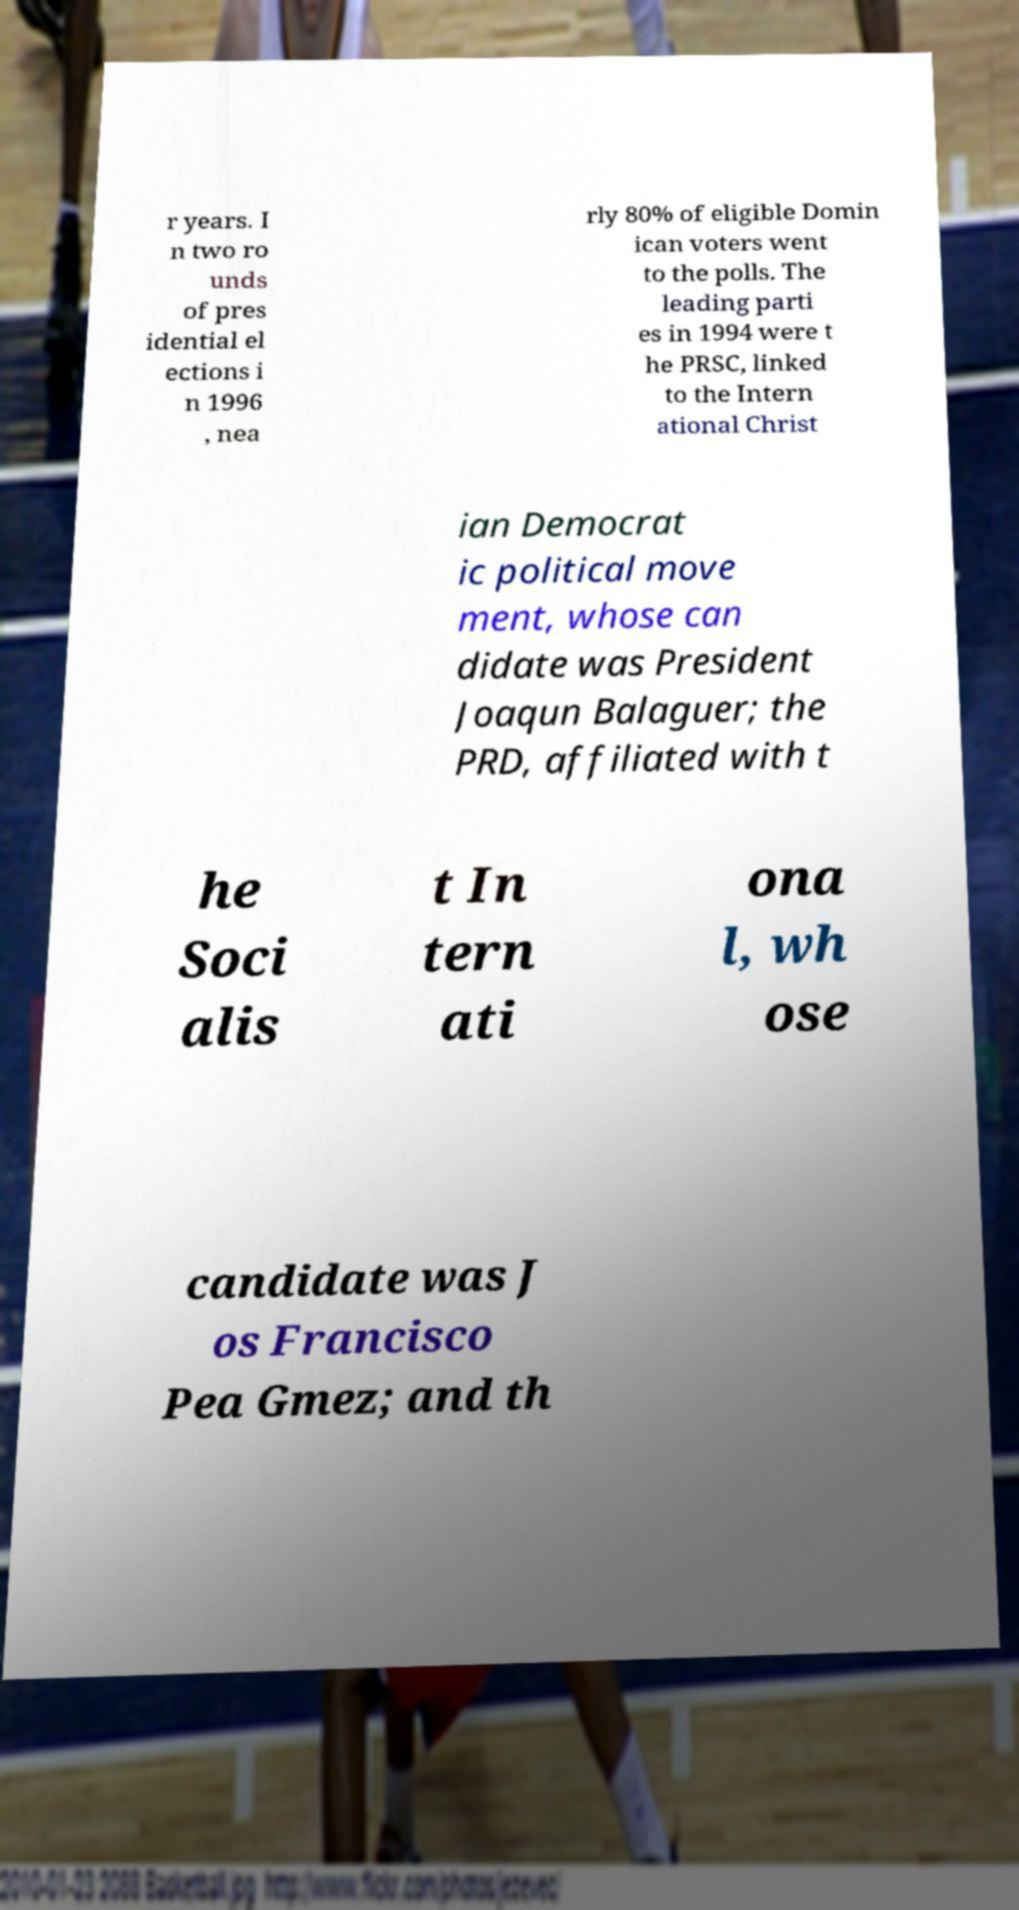Please read and relay the text visible in this image. What does it say? r years. I n two ro unds of pres idential el ections i n 1996 , nea rly 80% of eligible Domin ican voters went to the polls. The leading parti es in 1994 were t he PRSC, linked to the Intern ational Christ ian Democrat ic political move ment, whose can didate was President Joaqun Balaguer; the PRD, affiliated with t he Soci alis t In tern ati ona l, wh ose candidate was J os Francisco Pea Gmez; and th 